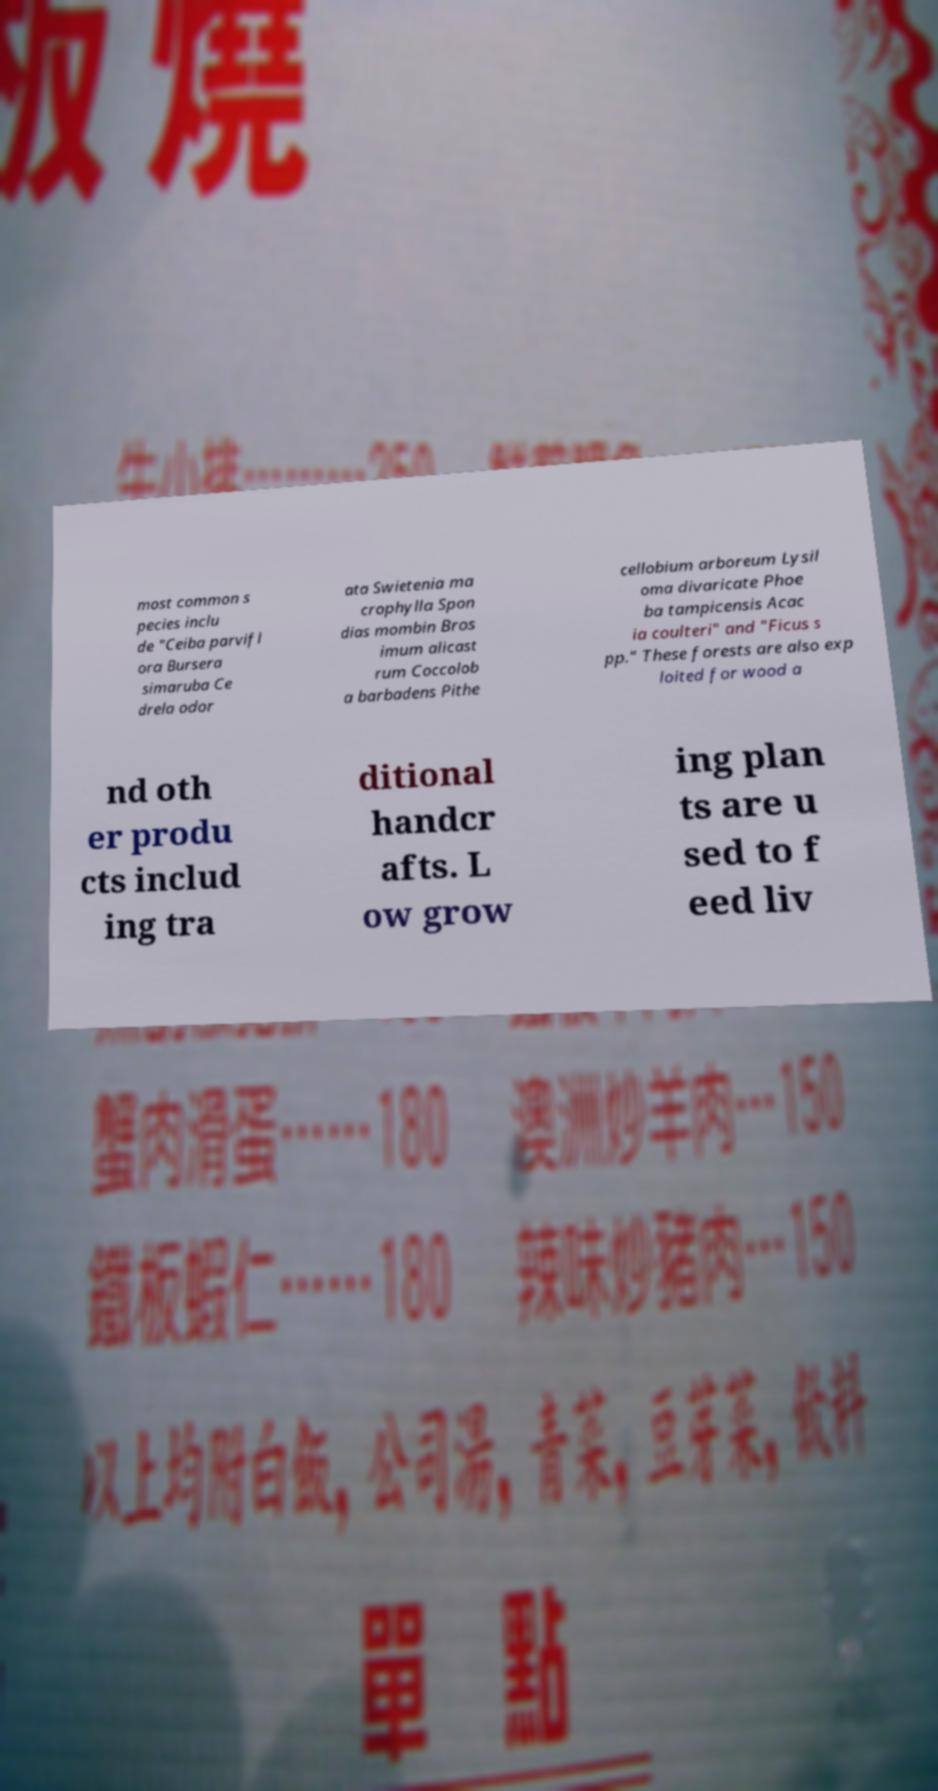Could you assist in decoding the text presented in this image and type it out clearly? most common s pecies inclu de "Ceiba parvifl ora Bursera simaruba Ce drela odor ata Swietenia ma crophylla Spon dias mombin Bros imum alicast rum Coccolob a barbadens Pithe cellobium arboreum Lysil oma divaricate Phoe ba tampicensis Acac ia coulteri" and "Ficus s pp." These forests are also exp loited for wood a nd oth er produ cts includ ing tra ditional handcr afts. L ow grow ing plan ts are u sed to f eed liv 